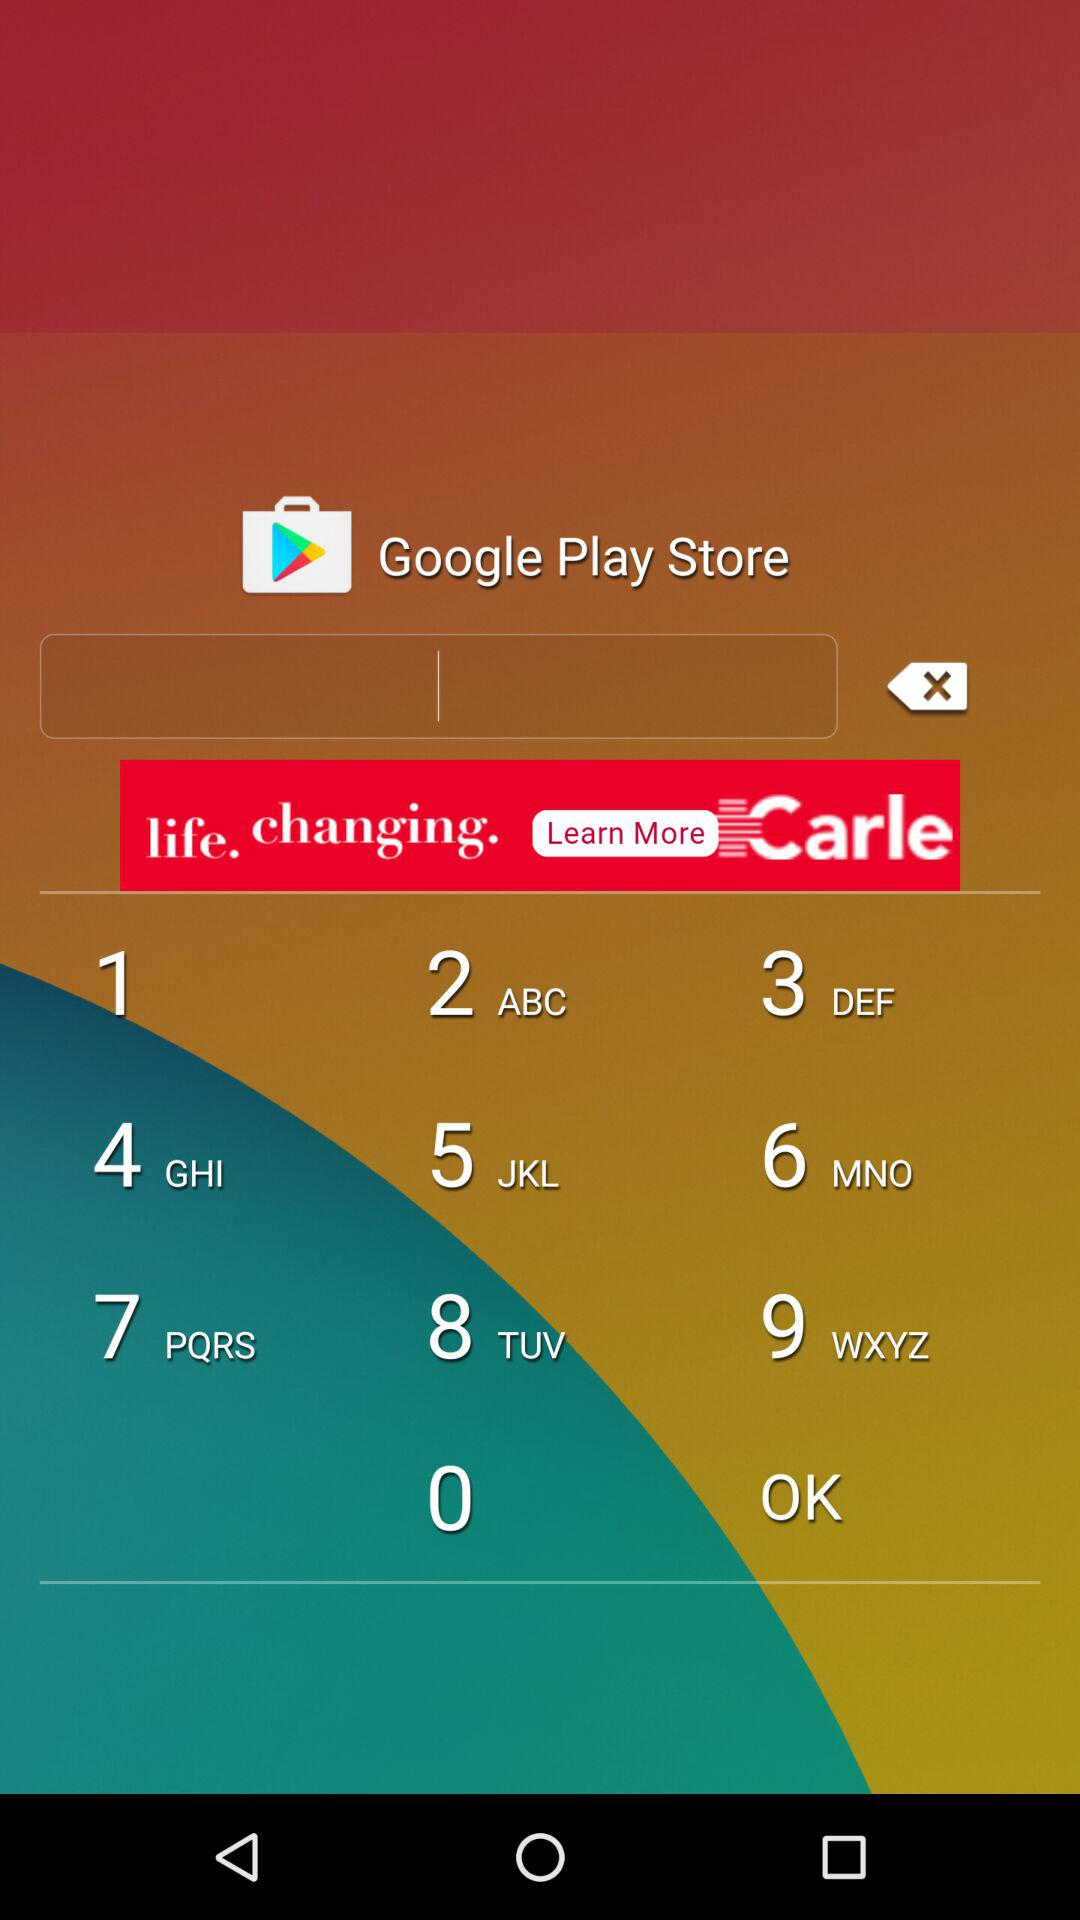What is the application name? The application name is "Google Play Store". 